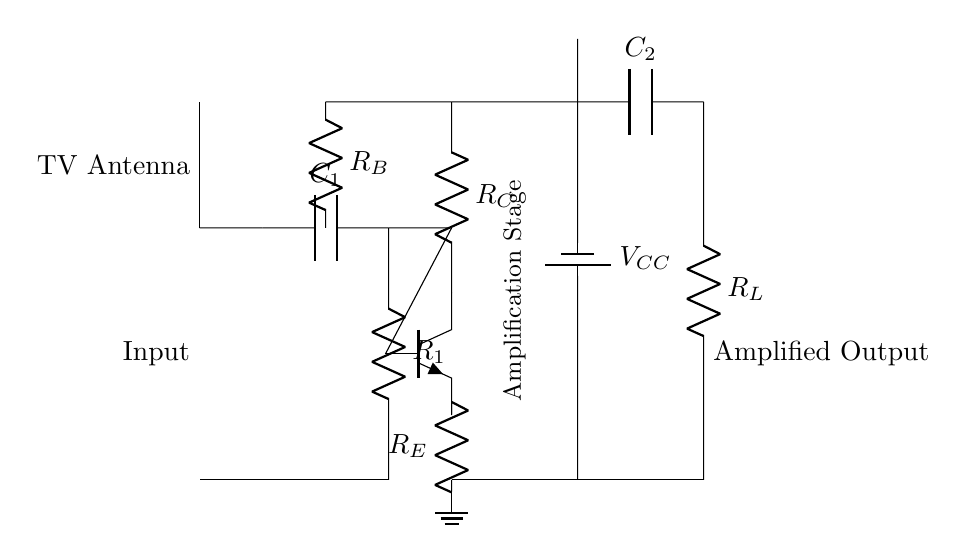What is the main function of this circuit? The main function of this circuit is to amplify weak signals from a TV antenna, boosting their strength for better reception.
Answer: Amplification What type of transistor is used in this circuit? The circuit uses an NPN transistor, which is indicated by the labeling of the transistor symbol.
Answer: NPN What is the purpose of the capacitor labeled C1? Capacitor C1 functions to block DC voltage while allowing AC signals from the antenna to pass through, effectively filtering out any unwanted DC components.
Answer: Block DC How many resistors are used in this circuit? The circuit contains three resistors: R1, R_C, and R_E, which are responsible for different functions such as biasing and load.
Answer: Three What is the value of the voltage source in this circuit? The circuit diagram specifies a voltage source labeled V_CC, which typically provides the necessary power to the circuit but does not specify a numerical value; it's a general notation for the power supply voltage.
Answer: V_CC What is the role of resistor R_B in this circuit? Resistor R_B is used for biasing the transistor, setting its operating point to ensure proper functioning in the amplification stage, allowing it to operate efficiently.
Answer: Biasing Which component provides the output signal? The output signal is taken across the load resistor R_L, which is connected to the amplifier's output stage, allowing the amplified signal to be delivered.
Answer: R_L 